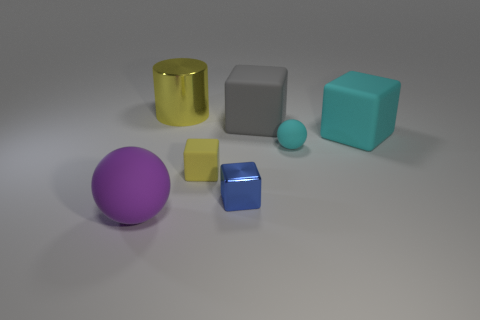What could the relative sizes of these objects suggest if this were a piece of abstract art? If this image were an abstract art piece, the relative sizes of the objects might represent the diversity of elements in a system, with each size suggesting a different level of influence or importance. Could the positioning of these objects carry any significance in that context? In an abstract art context, the thoughtful arrangement of these objects could imply balance and coexistence, or perhaps a commentary on the organized chaos found in nature or human society. 